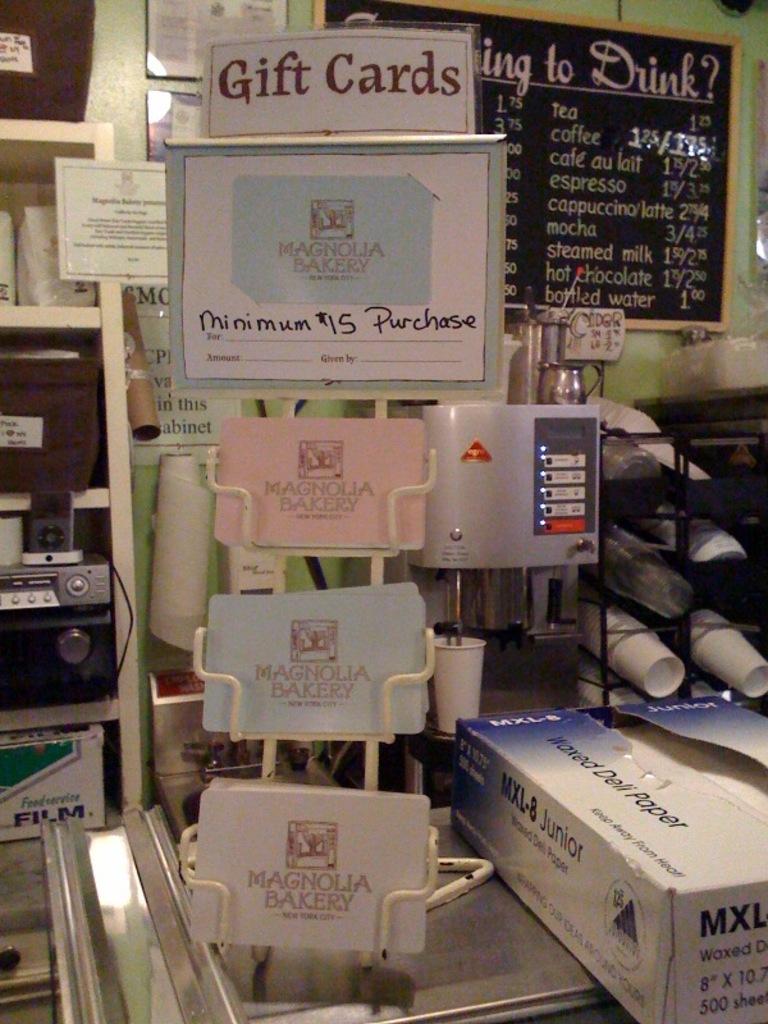What is the minimum purchase for gift cards?
Your answer should be compact. 15. 